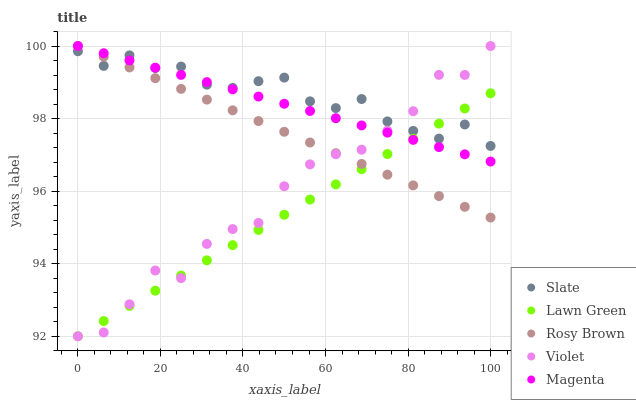Does Lawn Green have the minimum area under the curve?
Answer yes or no. Yes. Does Slate have the maximum area under the curve?
Answer yes or no. Yes. Does Rosy Brown have the minimum area under the curve?
Answer yes or no. No. Does Rosy Brown have the maximum area under the curve?
Answer yes or no. No. Is Magenta the smoothest?
Answer yes or no. Yes. Is Violet the roughest?
Answer yes or no. Yes. Is Slate the smoothest?
Answer yes or no. No. Is Slate the roughest?
Answer yes or no. No. Does Lawn Green have the lowest value?
Answer yes or no. Yes. Does Rosy Brown have the lowest value?
Answer yes or no. No. Does Magenta have the highest value?
Answer yes or no. Yes. Does Slate have the highest value?
Answer yes or no. No. Does Slate intersect Violet?
Answer yes or no. Yes. Is Slate less than Violet?
Answer yes or no. No. Is Slate greater than Violet?
Answer yes or no. No. 